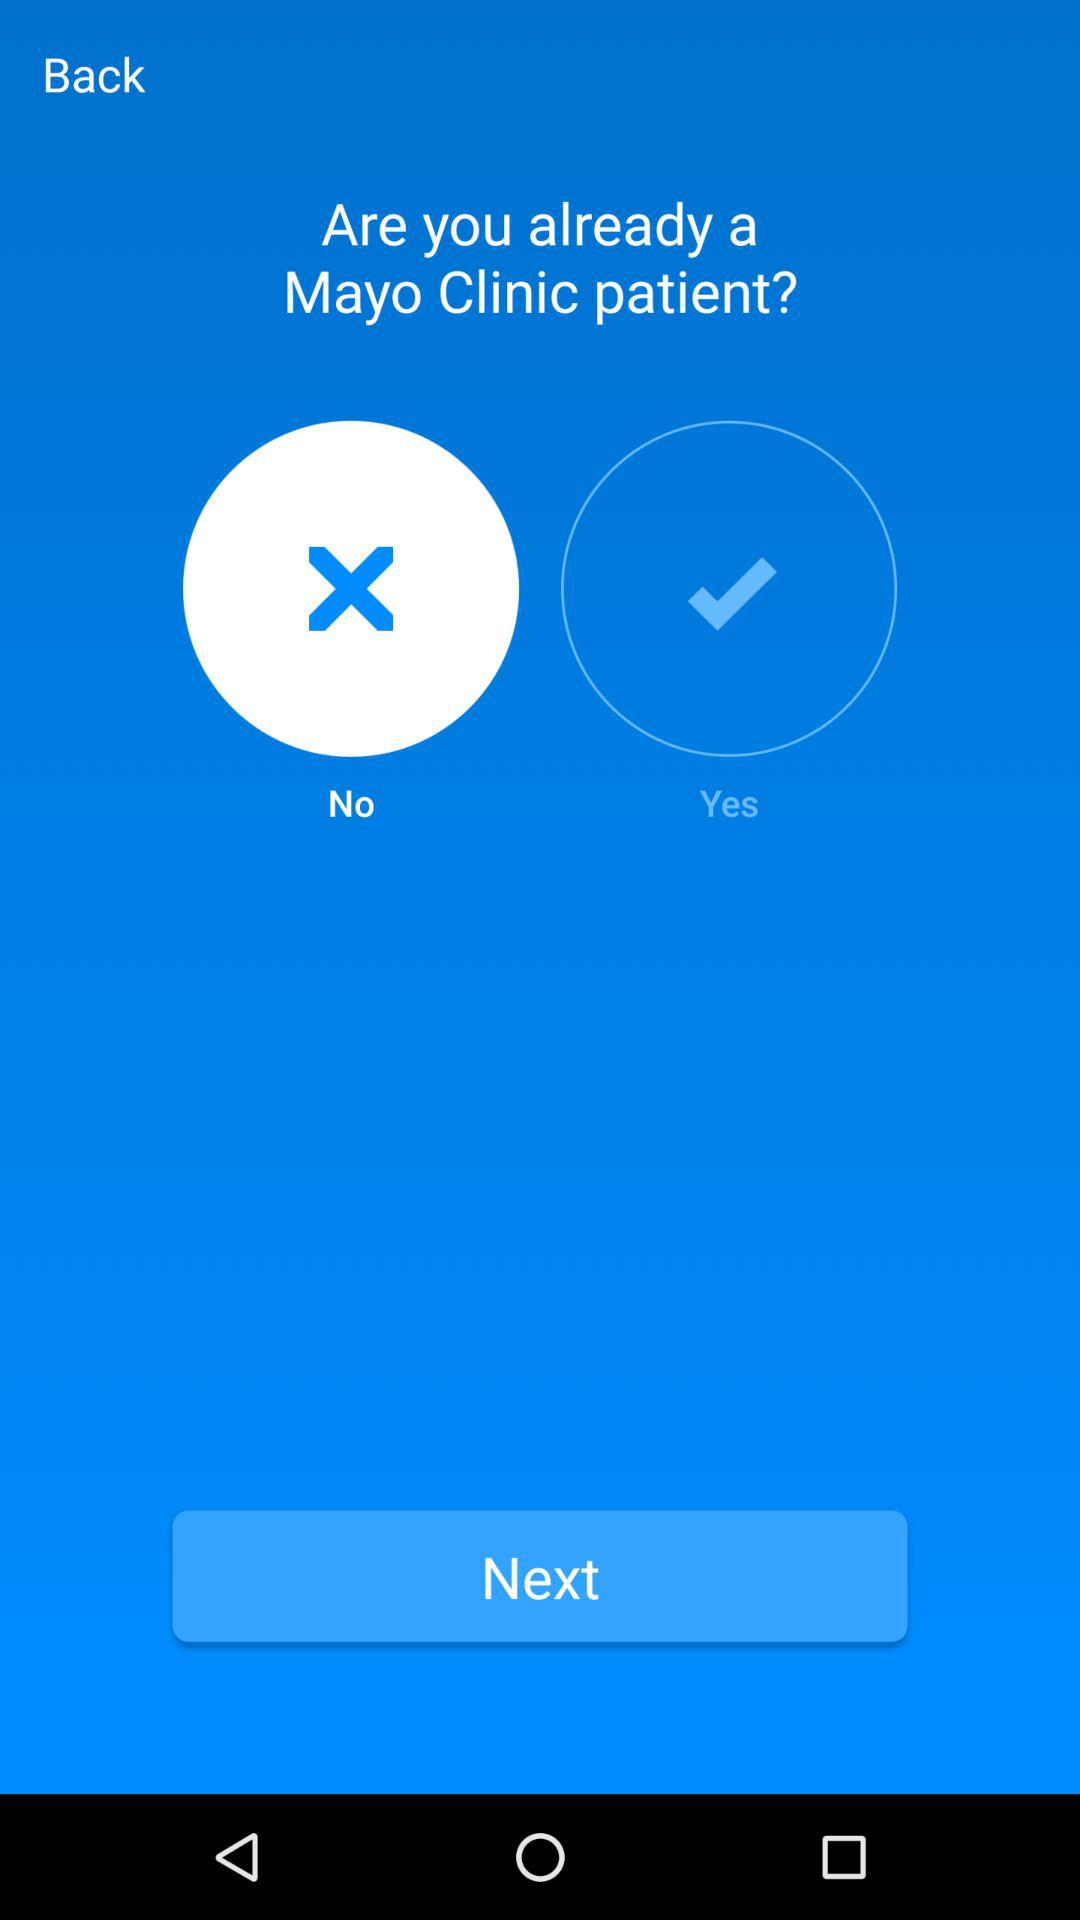How many options are there for the user to choose from?
Answer the question using a single word or phrase. 2 